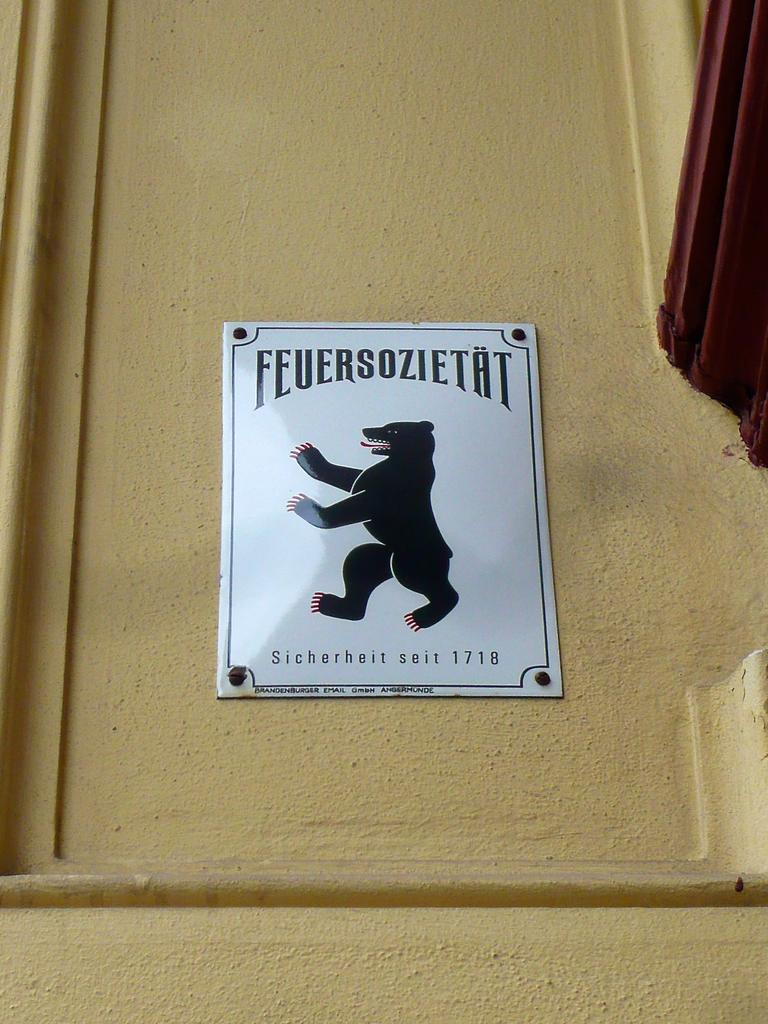What is featured on the poster in the image? The poster contains text and a picture of an animal. Can you describe the animal depicted on the poster? Unfortunately, the specific animal cannot be determined from the provided facts. What else is visible in the image besides the poster? There is a wall visible in the image. What type of hydrant is visible in the image? There is no hydrant present in the image; it only features a poster and a wall. 